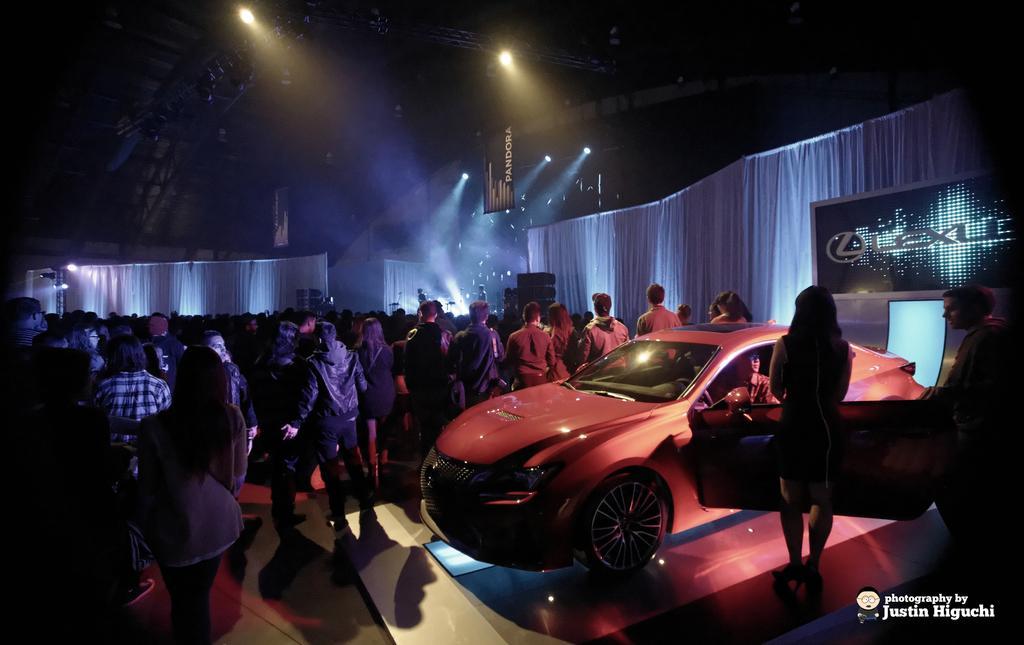Please provide a concise description of this image. In this picture we can see beams, lights, banners, people, white curtains, screen, floor and few objects. On the right side of the picture we can see a person is inside a car. We can see a man and woman. They both are standing. In the bottom right corner of the picture we can see watermark. 